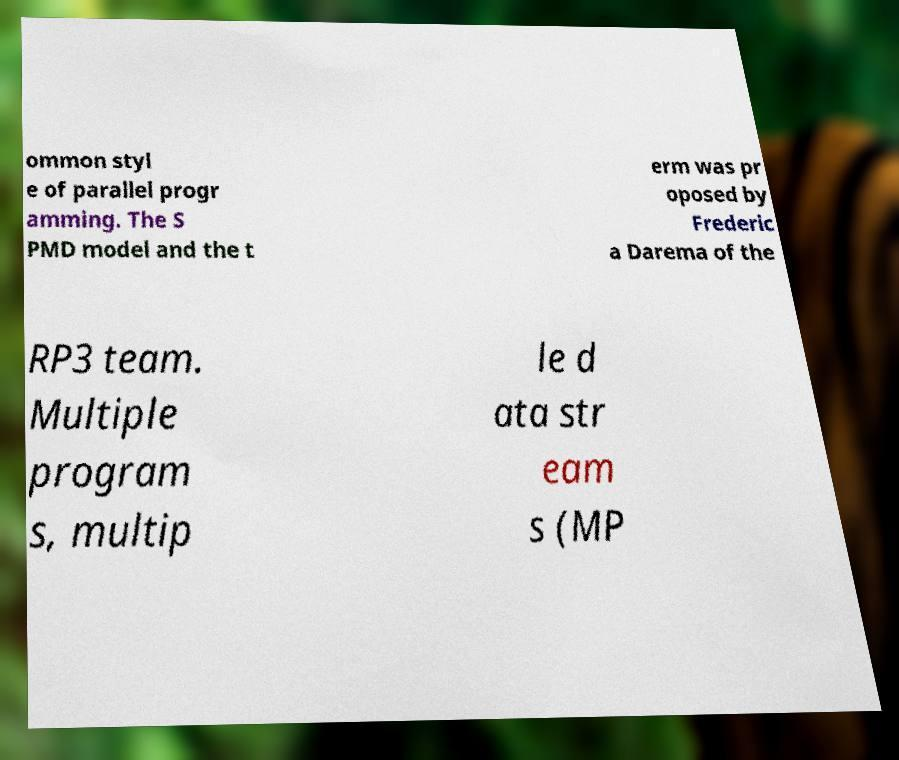Could you assist in decoding the text presented in this image and type it out clearly? ommon styl e of parallel progr amming. The S PMD model and the t erm was pr oposed by Frederic a Darema of the RP3 team. Multiple program s, multip le d ata str eam s (MP 